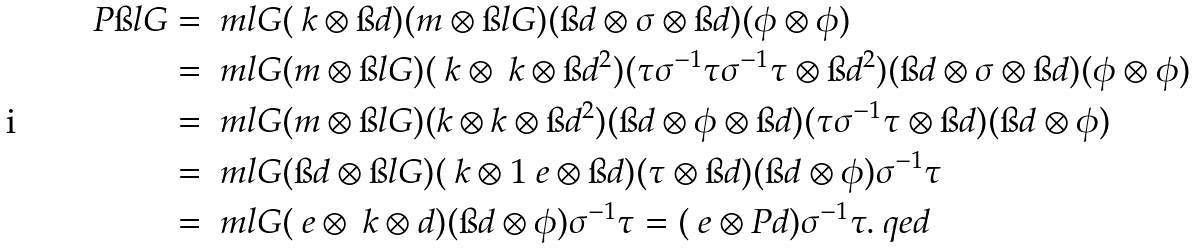Convert formula to latex. <formula><loc_0><loc_0><loc_500><loc_500>P \i l G & = \ m l G ( \ k \otimes \i d ) ( m \otimes \i l G ) ( \i d \otimes \sigma \otimes \i d ) ( \phi \otimes \phi ) \\ & = \ m l G ( m \otimes \i l G ) ( \ k \otimes \ k \otimes \i d ^ { 2 } ) ( \tau \sigma ^ { - 1 } \tau \sigma ^ { - 1 } \tau \otimes \i d ^ { 2 } ) ( \i d \otimes \sigma \otimes \i d ) ( \phi \otimes \phi ) \\ & = \ m l G ( m \otimes \i l G ) ( k \otimes k \otimes \i d ^ { 2 } ) ( \i d \otimes \phi \otimes \i d ) ( \tau \sigma ^ { - 1 } \tau \otimes \i d ) ( \i d \otimes \phi ) \\ & = \ m l G ( \i d \otimes \i l G ) ( \ k \otimes 1 \ e \otimes \i d ) ( \tau \otimes \i d ) ( \i d \otimes \phi ) \sigma ^ { - 1 } \tau \\ & = \ m l G ( \ e \otimes \ k \otimes d ) ( \i d \otimes \phi ) \sigma ^ { - 1 } \tau = ( \ e \otimes P d ) \sigma ^ { - 1 } \tau . \ q e d</formula> 